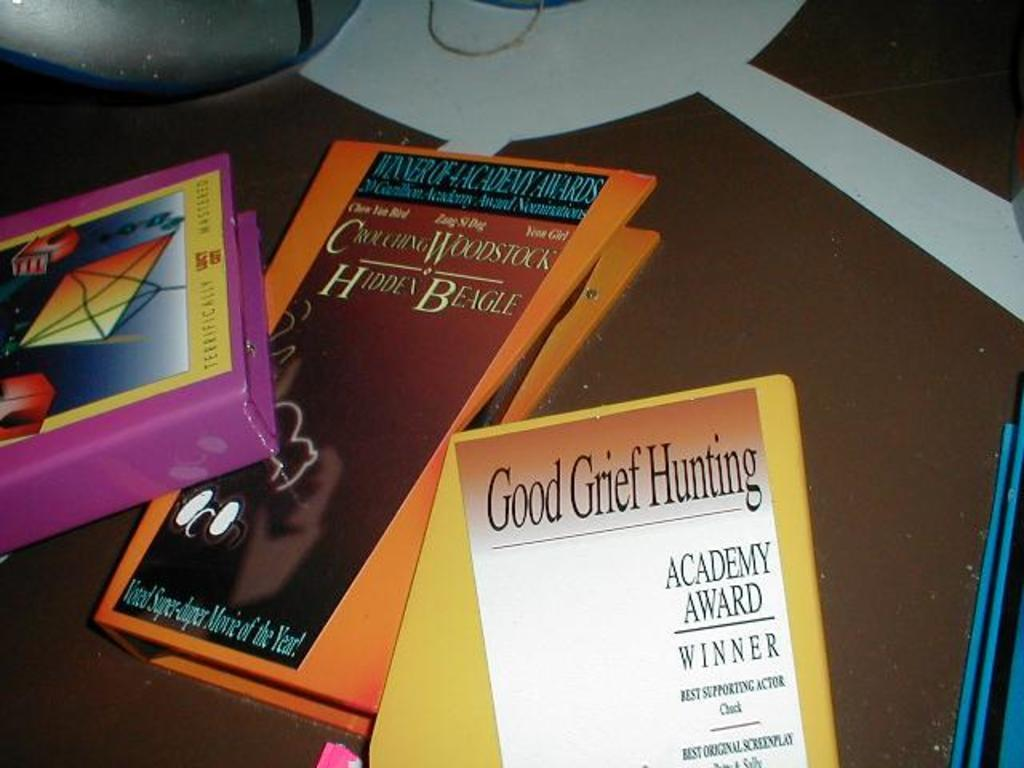Provide a one-sentence caption for the provided image. Good Grief Hunting is the title of a book on a table with others. 